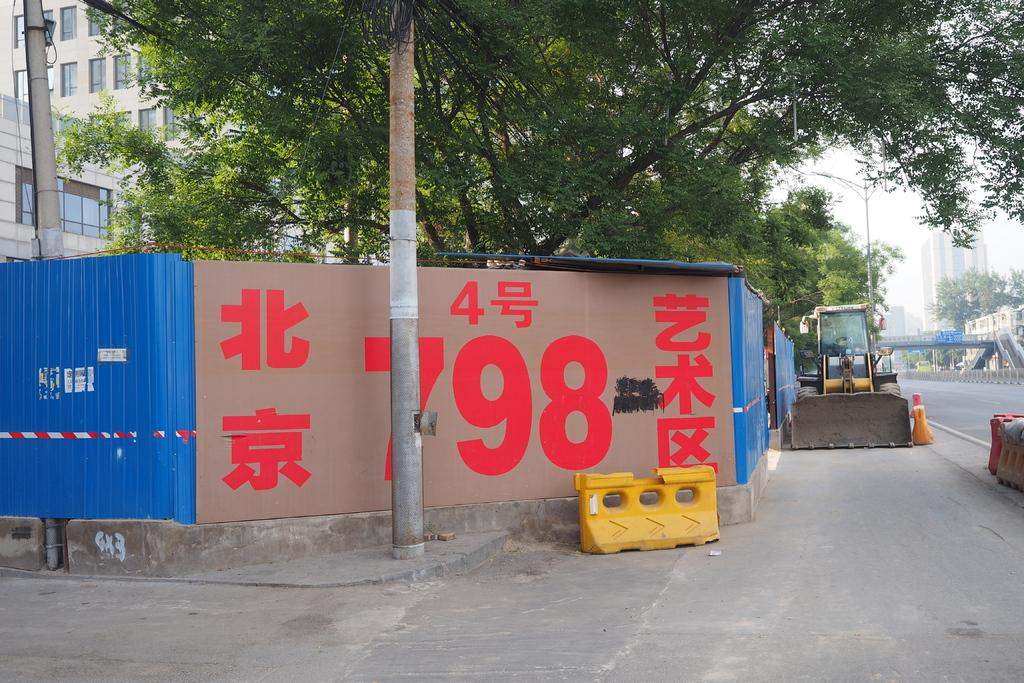<image>
Describe the image concisely. Giant sign that has the number 798 on it. 